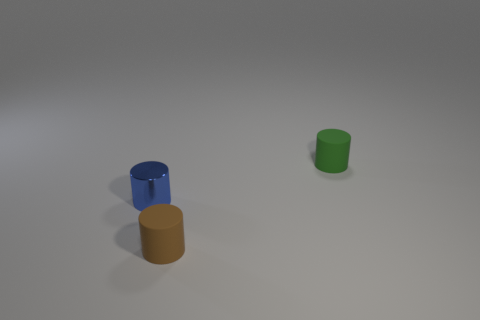Can you describe the objects in the image? There are three cylindrical objects in the image, each with varying heights and colors. The blue and the orange objects are lying on their sides, while the green one is standing upright. Their surfaces are smooth and there is a soft light casting gentle shadows on the ground, indicating an indoor setting with controlled lighting.  What could these objects be used for? These objects could be simplistic representations of containers or cups, possibly utilized for educational or demonstration purposes given their idealized shapes and monochrome coloration. They could serve as part of a visual aid for teaching shapes, colors, and spatial orientation or even for a computer graphics rendering demonstration. 